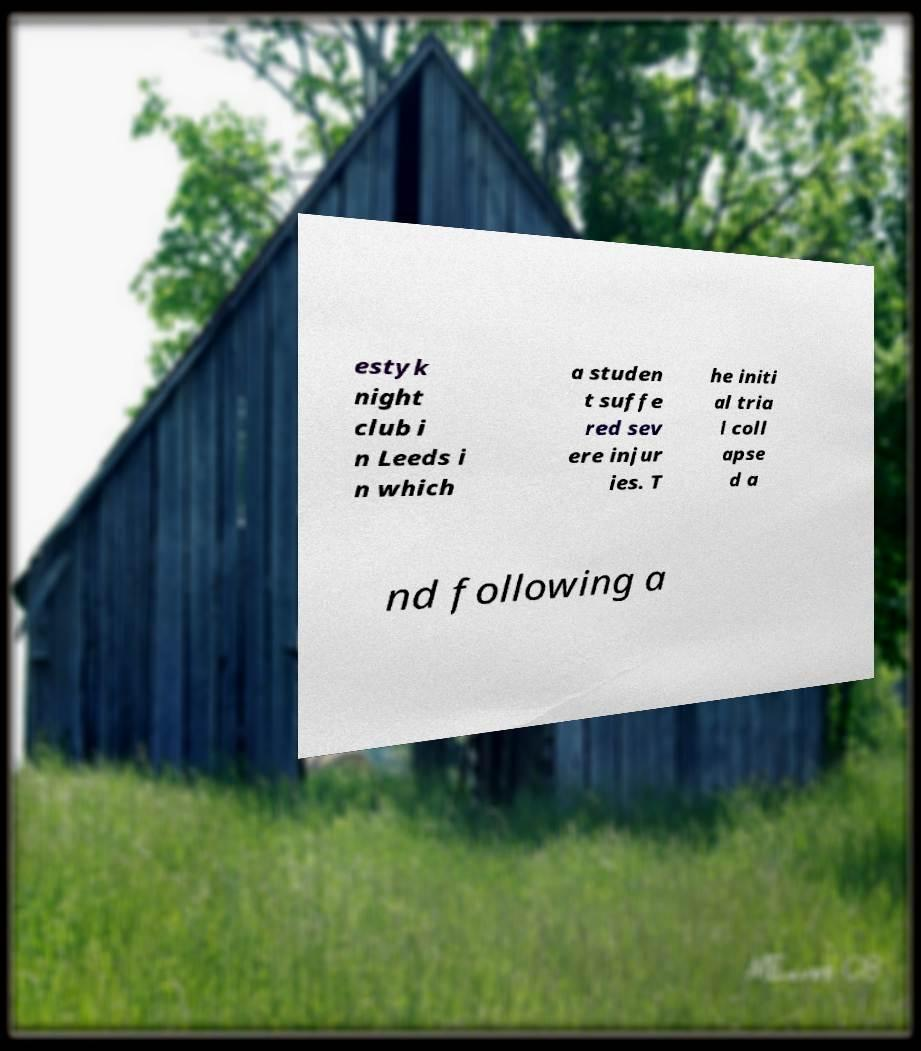For documentation purposes, I need the text within this image transcribed. Could you provide that? estyk night club i n Leeds i n which a studen t suffe red sev ere injur ies. T he initi al tria l coll apse d a nd following a 